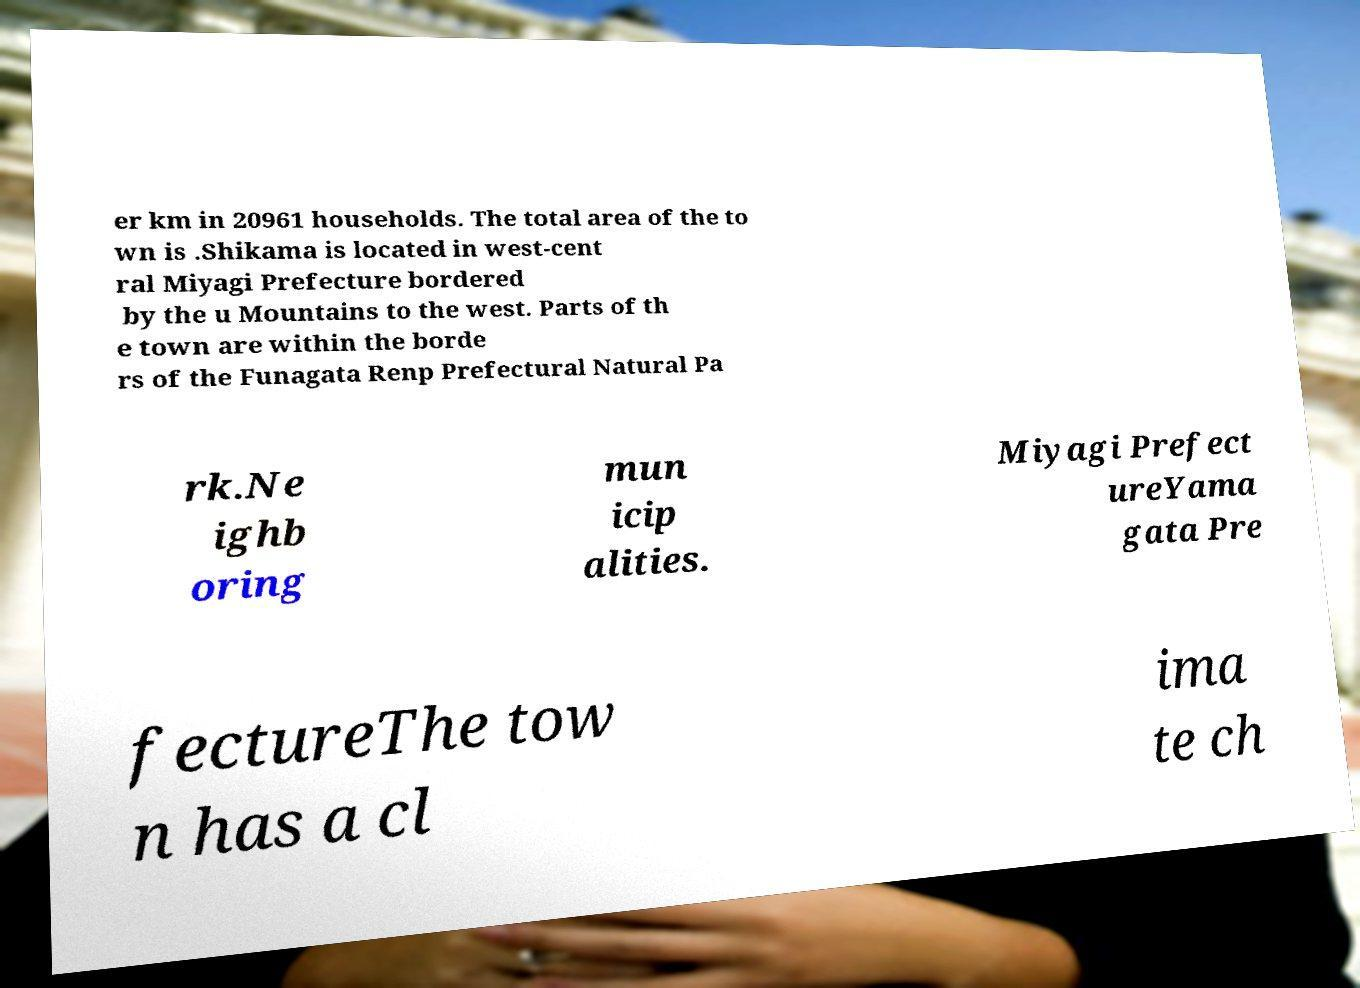I need the written content from this picture converted into text. Can you do that? er km in 20961 households. The total area of the to wn is .Shikama is located in west-cent ral Miyagi Prefecture bordered by the u Mountains to the west. Parts of th e town are within the borde rs of the Funagata Renp Prefectural Natural Pa rk.Ne ighb oring mun icip alities. Miyagi Prefect ureYama gata Pre fectureThe tow n has a cl ima te ch 